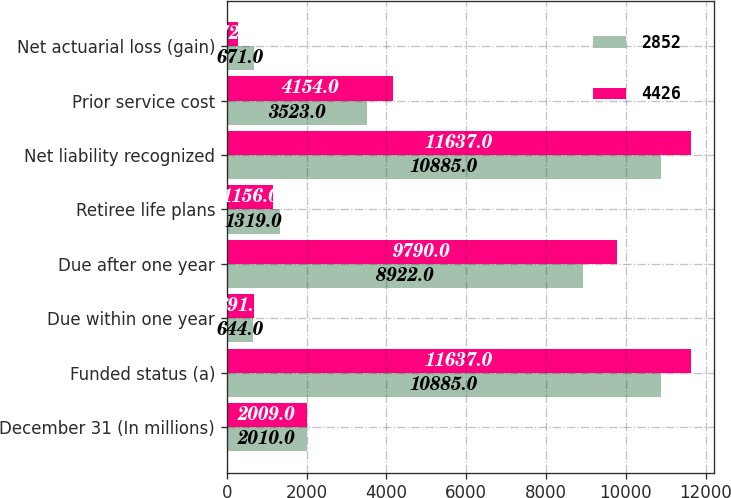Convert chart. <chart><loc_0><loc_0><loc_500><loc_500><stacked_bar_chart><ecel><fcel>December 31 (In millions)<fcel>Funded status (a)<fcel>Due within one year<fcel>Due after one year<fcel>Retiree life plans<fcel>Net liability recognized<fcel>Prior service cost<fcel>Net actuarial loss (gain)<nl><fcel>2852<fcel>2010<fcel>10885<fcel>644<fcel>8922<fcel>1319<fcel>10885<fcel>3523<fcel>671<nl><fcel>4426<fcel>2009<fcel>11637<fcel>691<fcel>9790<fcel>1156<fcel>11637<fcel>4154<fcel>272<nl></chart> 